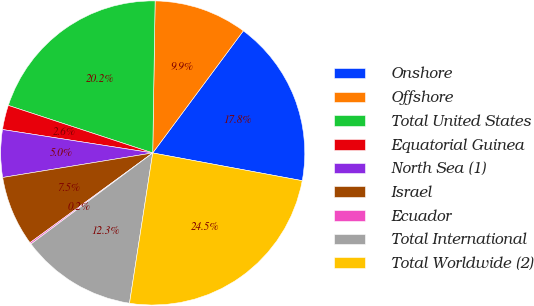Convert chart to OTSL. <chart><loc_0><loc_0><loc_500><loc_500><pie_chart><fcel>Onshore<fcel>Offshore<fcel>Total United States<fcel>Equatorial Guinea<fcel>North Sea (1)<fcel>Israel<fcel>Ecuador<fcel>Total International<fcel>Total Worldwide (2)<nl><fcel>17.76%<fcel>9.91%<fcel>20.19%<fcel>2.6%<fcel>5.04%<fcel>7.47%<fcel>0.17%<fcel>12.34%<fcel>24.52%<nl></chart> 